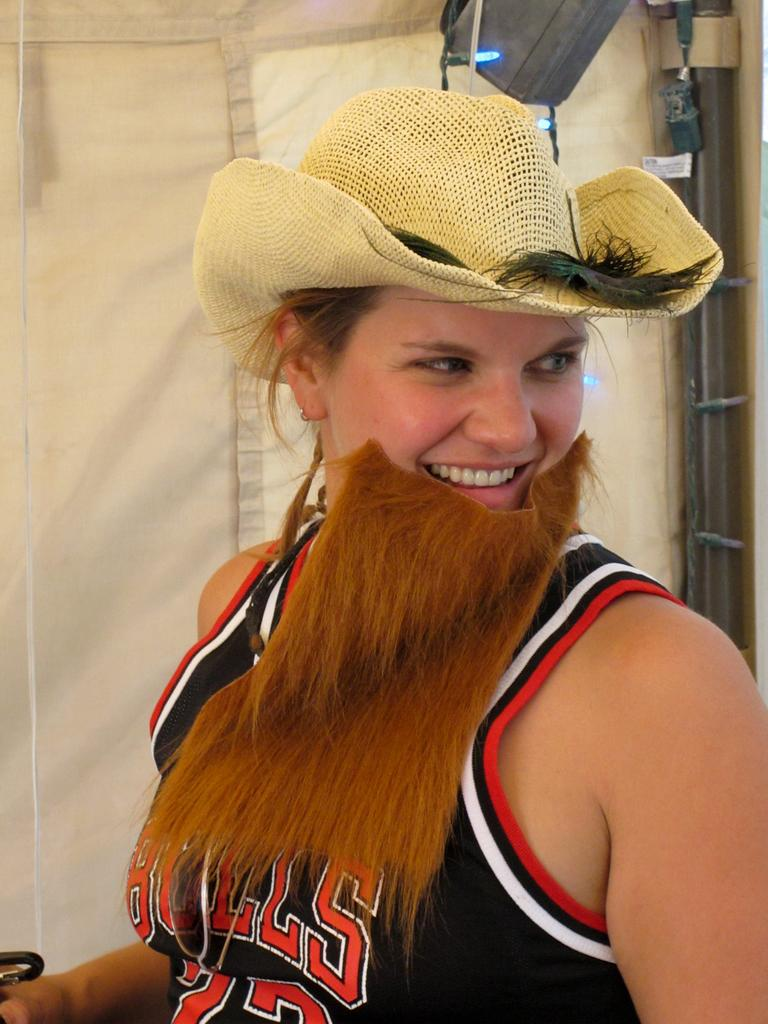Provide a one-sentence caption for the provided image. A woman with a fake beard and cowboy hat is wearing a Bulls jersey. 